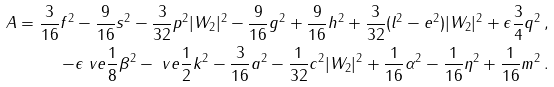Convert formula to latex. <formula><loc_0><loc_0><loc_500><loc_500>A = \frac { 3 } { 1 6 } f ^ { 2 } - \frac { 9 } { 1 6 } s ^ { 2 } - \frac { 3 } { 3 2 } p ^ { 2 } | W _ { 2 } | ^ { 2 } - \frac { 9 } { 1 6 } g ^ { 2 } + \frac { 9 } { 1 6 } h ^ { 2 } + \frac { 3 } { 3 2 } ( l ^ { 2 } - e ^ { 2 } ) | W _ { 2 } | ^ { 2 } + \epsilon \frac { 3 } { 4 } q ^ { 2 } & \, , \\ - \epsilon \ v e \frac { 1 } { 8 } \beta ^ { 2 } - \ v e \frac { 1 } { 2 } k ^ { 2 } - \frac { 3 } { 1 6 } a ^ { 2 } - \frac { 1 } { 3 2 } c ^ { 2 } | W _ { 2 } | ^ { 2 } + \frac { 1 } { 1 6 } \alpha ^ { 2 } - \frac { 1 } { 1 6 } \eta ^ { 2 } + \frac { 1 } { 1 6 } m ^ { 2 } & \, .</formula> 